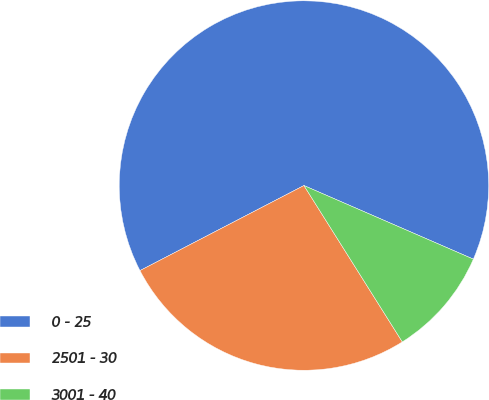<chart> <loc_0><loc_0><loc_500><loc_500><pie_chart><fcel>0 - 25<fcel>2501 - 30<fcel>3001 - 40<nl><fcel>64.14%<fcel>26.32%<fcel>9.54%<nl></chart> 